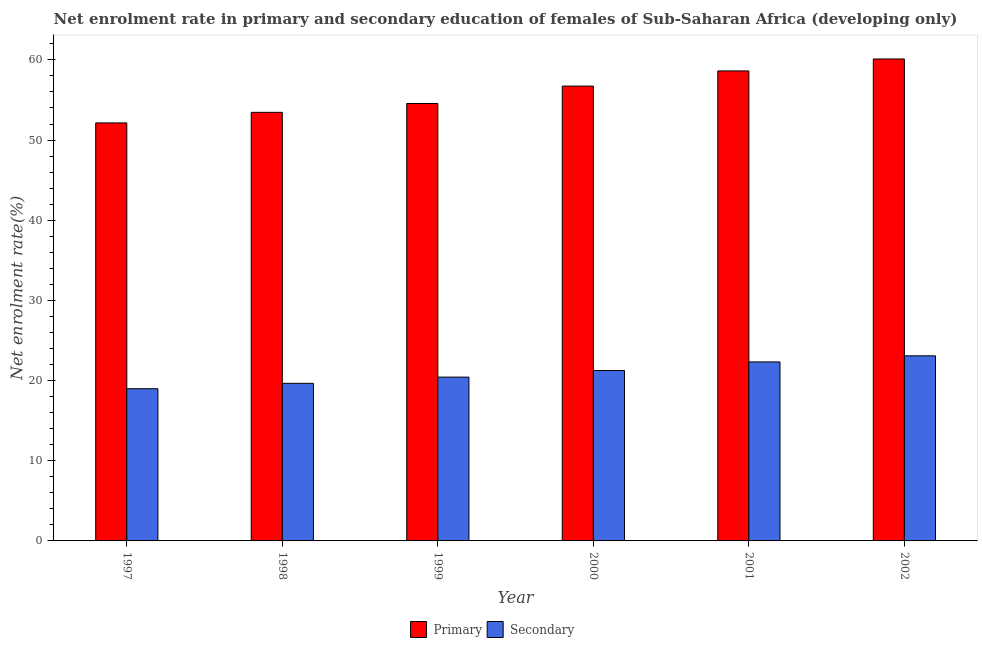How many different coloured bars are there?
Keep it short and to the point. 2. Are the number of bars on each tick of the X-axis equal?
Offer a very short reply. Yes. How many bars are there on the 6th tick from the left?
Give a very brief answer. 2. How many bars are there on the 2nd tick from the right?
Ensure brevity in your answer.  2. What is the enrollment rate in primary education in 1999?
Ensure brevity in your answer.  54.56. Across all years, what is the maximum enrollment rate in secondary education?
Make the answer very short. 23.09. Across all years, what is the minimum enrollment rate in secondary education?
Offer a very short reply. 18.99. In which year was the enrollment rate in primary education maximum?
Your response must be concise. 2002. What is the total enrollment rate in primary education in the graph?
Give a very brief answer. 335.63. What is the difference between the enrollment rate in primary education in 1998 and that in 2001?
Keep it short and to the point. -5.16. What is the difference between the enrollment rate in secondary education in 1998 and the enrollment rate in primary education in 2000?
Provide a short and direct response. -1.6. What is the average enrollment rate in secondary education per year?
Ensure brevity in your answer.  20.96. In the year 2000, what is the difference between the enrollment rate in primary education and enrollment rate in secondary education?
Ensure brevity in your answer.  0. What is the ratio of the enrollment rate in secondary education in 1998 to that in 2001?
Ensure brevity in your answer.  0.88. Is the enrollment rate in primary education in 2000 less than that in 2001?
Your answer should be compact. Yes. Is the difference between the enrollment rate in primary education in 1997 and 2000 greater than the difference between the enrollment rate in secondary education in 1997 and 2000?
Provide a succinct answer. No. What is the difference between the highest and the second highest enrollment rate in secondary education?
Your answer should be very brief. 0.76. What is the difference between the highest and the lowest enrollment rate in primary education?
Provide a short and direct response. 7.98. Is the sum of the enrollment rate in secondary education in 1997 and 2001 greater than the maximum enrollment rate in primary education across all years?
Your answer should be compact. Yes. What does the 1st bar from the left in 2001 represents?
Provide a short and direct response. Primary. What does the 1st bar from the right in 2001 represents?
Ensure brevity in your answer.  Secondary. What is the difference between two consecutive major ticks on the Y-axis?
Offer a terse response. 10. Are the values on the major ticks of Y-axis written in scientific E-notation?
Provide a short and direct response. No. Does the graph contain any zero values?
Make the answer very short. No. How many legend labels are there?
Make the answer very short. 2. How are the legend labels stacked?
Provide a succinct answer. Horizontal. What is the title of the graph?
Your answer should be compact. Net enrolment rate in primary and secondary education of females of Sub-Saharan Africa (developing only). What is the label or title of the Y-axis?
Offer a very short reply. Net enrolment rate(%). What is the Net enrolment rate(%) in Primary in 1997?
Your response must be concise. 52.14. What is the Net enrolment rate(%) of Secondary in 1997?
Offer a terse response. 18.99. What is the Net enrolment rate(%) of Primary in 1998?
Offer a very short reply. 53.46. What is the Net enrolment rate(%) of Secondary in 1998?
Ensure brevity in your answer.  19.66. What is the Net enrolment rate(%) in Primary in 1999?
Provide a succinct answer. 54.56. What is the Net enrolment rate(%) in Secondary in 1999?
Provide a short and direct response. 20.43. What is the Net enrolment rate(%) of Primary in 2000?
Offer a very short reply. 56.74. What is the Net enrolment rate(%) of Secondary in 2000?
Offer a terse response. 21.26. What is the Net enrolment rate(%) in Primary in 2001?
Keep it short and to the point. 58.62. What is the Net enrolment rate(%) in Secondary in 2001?
Ensure brevity in your answer.  22.33. What is the Net enrolment rate(%) of Primary in 2002?
Offer a terse response. 60.11. What is the Net enrolment rate(%) in Secondary in 2002?
Keep it short and to the point. 23.09. Across all years, what is the maximum Net enrolment rate(%) of Primary?
Offer a very short reply. 60.11. Across all years, what is the maximum Net enrolment rate(%) of Secondary?
Your answer should be very brief. 23.09. Across all years, what is the minimum Net enrolment rate(%) in Primary?
Offer a very short reply. 52.14. Across all years, what is the minimum Net enrolment rate(%) of Secondary?
Provide a short and direct response. 18.99. What is the total Net enrolment rate(%) of Primary in the graph?
Keep it short and to the point. 335.63. What is the total Net enrolment rate(%) of Secondary in the graph?
Your answer should be very brief. 125.74. What is the difference between the Net enrolment rate(%) of Primary in 1997 and that in 1998?
Provide a succinct answer. -1.32. What is the difference between the Net enrolment rate(%) of Secondary in 1997 and that in 1998?
Keep it short and to the point. -0.67. What is the difference between the Net enrolment rate(%) in Primary in 1997 and that in 1999?
Your response must be concise. -2.42. What is the difference between the Net enrolment rate(%) of Secondary in 1997 and that in 1999?
Ensure brevity in your answer.  -1.45. What is the difference between the Net enrolment rate(%) of Primary in 1997 and that in 2000?
Make the answer very short. -4.6. What is the difference between the Net enrolment rate(%) of Secondary in 1997 and that in 2000?
Keep it short and to the point. -2.27. What is the difference between the Net enrolment rate(%) of Primary in 1997 and that in 2001?
Offer a very short reply. -6.48. What is the difference between the Net enrolment rate(%) in Secondary in 1997 and that in 2001?
Provide a short and direct response. -3.34. What is the difference between the Net enrolment rate(%) of Primary in 1997 and that in 2002?
Offer a very short reply. -7.98. What is the difference between the Net enrolment rate(%) of Secondary in 1997 and that in 2002?
Make the answer very short. -4.1. What is the difference between the Net enrolment rate(%) of Primary in 1998 and that in 1999?
Keep it short and to the point. -1.1. What is the difference between the Net enrolment rate(%) of Secondary in 1998 and that in 1999?
Keep it short and to the point. -0.78. What is the difference between the Net enrolment rate(%) in Primary in 1998 and that in 2000?
Your response must be concise. -3.28. What is the difference between the Net enrolment rate(%) of Secondary in 1998 and that in 2000?
Give a very brief answer. -1.6. What is the difference between the Net enrolment rate(%) in Primary in 1998 and that in 2001?
Offer a very short reply. -5.16. What is the difference between the Net enrolment rate(%) of Secondary in 1998 and that in 2001?
Your answer should be very brief. -2.67. What is the difference between the Net enrolment rate(%) in Primary in 1998 and that in 2002?
Offer a terse response. -6.66. What is the difference between the Net enrolment rate(%) in Secondary in 1998 and that in 2002?
Offer a very short reply. -3.43. What is the difference between the Net enrolment rate(%) of Primary in 1999 and that in 2000?
Provide a succinct answer. -2.17. What is the difference between the Net enrolment rate(%) in Secondary in 1999 and that in 2000?
Provide a short and direct response. -0.83. What is the difference between the Net enrolment rate(%) in Primary in 1999 and that in 2001?
Give a very brief answer. -4.06. What is the difference between the Net enrolment rate(%) of Secondary in 1999 and that in 2001?
Make the answer very short. -1.89. What is the difference between the Net enrolment rate(%) in Primary in 1999 and that in 2002?
Offer a very short reply. -5.55. What is the difference between the Net enrolment rate(%) in Secondary in 1999 and that in 2002?
Provide a short and direct response. -2.66. What is the difference between the Net enrolment rate(%) of Primary in 2000 and that in 2001?
Keep it short and to the point. -1.89. What is the difference between the Net enrolment rate(%) in Secondary in 2000 and that in 2001?
Your response must be concise. -1.07. What is the difference between the Net enrolment rate(%) of Primary in 2000 and that in 2002?
Offer a terse response. -3.38. What is the difference between the Net enrolment rate(%) in Secondary in 2000 and that in 2002?
Give a very brief answer. -1.83. What is the difference between the Net enrolment rate(%) in Primary in 2001 and that in 2002?
Your answer should be very brief. -1.49. What is the difference between the Net enrolment rate(%) in Secondary in 2001 and that in 2002?
Your answer should be very brief. -0.76. What is the difference between the Net enrolment rate(%) in Primary in 1997 and the Net enrolment rate(%) in Secondary in 1998?
Keep it short and to the point. 32.48. What is the difference between the Net enrolment rate(%) in Primary in 1997 and the Net enrolment rate(%) in Secondary in 1999?
Your answer should be very brief. 31.71. What is the difference between the Net enrolment rate(%) of Primary in 1997 and the Net enrolment rate(%) of Secondary in 2000?
Your answer should be very brief. 30.88. What is the difference between the Net enrolment rate(%) of Primary in 1997 and the Net enrolment rate(%) of Secondary in 2001?
Keep it short and to the point. 29.81. What is the difference between the Net enrolment rate(%) of Primary in 1997 and the Net enrolment rate(%) of Secondary in 2002?
Your answer should be compact. 29.05. What is the difference between the Net enrolment rate(%) of Primary in 1998 and the Net enrolment rate(%) of Secondary in 1999?
Keep it short and to the point. 33.03. What is the difference between the Net enrolment rate(%) in Primary in 1998 and the Net enrolment rate(%) in Secondary in 2000?
Your response must be concise. 32.2. What is the difference between the Net enrolment rate(%) in Primary in 1998 and the Net enrolment rate(%) in Secondary in 2001?
Make the answer very short. 31.13. What is the difference between the Net enrolment rate(%) of Primary in 1998 and the Net enrolment rate(%) of Secondary in 2002?
Give a very brief answer. 30.37. What is the difference between the Net enrolment rate(%) in Primary in 1999 and the Net enrolment rate(%) in Secondary in 2000?
Your answer should be compact. 33.31. What is the difference between the Net enrolment rate(%) in Primary in 1999 and the Net enrolment rate(%) in Secondary in 2001?
Give a very brief answer. 32.24. What is the difference between the Net enrolment rate(%) in Primary in 1999 and the Net enrolment rate(%) in Secondary in 2002?
Make the answer very short. 31.47. What is the difference between the Net enrolment rate(%) in Primary in 2000 and the Net enrolment rate(%) in Secondary in 2001?
Make the answer very short. 34.41. What is the difference between the Net enrolment rate(%) in Primary in 2000 and the Net enrolment rate(%) in Secondary in 2002?
Offer a very short reply. 33.65. What is the difference between the Net enrolment rate(%) in Primary in 2001 and the Net enrolment rate(%) in Secondary in 2002?
Your answer should be compact. 35.53. What is the average Net enrolment rate(%) in Primary per year?
Keep it short and to the point. 55.94. What is the average Net enrolment rate(%) in Secondary per year?
Your answer should be compact. 20.96. In the year 1997, what is the difference between the Net enrolment rate(%) in Primary and Net enrolment rate(%) in Secondary?
Keep it short and to the point. 33.15. In the year 1998, what is the difference between the Net enrolment rate(%) of Primary and Net enrolment rate(%) of Secondary?
Provide a succinct answer. 33.8. In the year 1999, what is the difference between the Net enrolment rate(%) in Primary and Net enrolment rate(%) in Secondary?
Give a very brief answer. 34.13. In the year 2000, what is the difference between the Net enrolment rate(%) in Primary and Net enrolment rate(%) in Secondary?
Your answer should be very brief. 35.48. In the year 2001, what is the difference between the Net enrolment rate(%) of Primary and Net enrolment rate(%) of Secondary?
Make the answer very short. 36.3. In the year 2002, what is the difference between the Net enrolment rate(%) in Primary and Net enrolment rate(%) in Secondary?
Your answer should be very brief. 37.03. What is the ratio of the Net enrolment rate(%) of Primary in 1997 to that in 1998?
Offer a very short reply. 0.98. What is the ratio of the Net enrolment rate(%) of Secondary in 1997 to that in 1998?
Make the answer very short. 0.97. What is the ratio of the Net enrolment rate(%) in Primary in 1997 to that in 1999?
Provide a succinct answer. 0.96. What is the ratio of the Net enrolment rate(%) in Secondary in 1997 to that in 1999?
Your answer should be compact. 0.93. What is the ratio of the Net enrolment rate(%) of Primary in 1997 to that in 2000?
Offer a very short reply. 0.92. What is the ratio of the Net enrolment rate(%) of Secondary in 1997 to that in 2000?
Give a very brief answer. 0.89. What is the ratio of the Net enrolment rate(%) in Primary in 1997 to that in 2001?
Offer a very short reply. 0.89. What is the ratio of the Net enrolment rate(%) in Secondary in 1997 to that in 2001?
Offer a terse response. 0.85. What is the ratio of the Net enrolment rate(%) in Primary in 1997 to that in 2002?
Keep it short and to the point. 0.87. What is the ratio of the Net enrolment rate(%) of Secondary in 1997 to that in 2002?
Make the answer very short. 0.82. What is the ratio of the Net enrolment rate(%) in Primary in 1998 to that in 1999?
Your answer should be very brief. 0.98. What is the ratio of the Net enrolment rate(%) in Secondary in 1998 to that in 1999?
Your response must be concise. 0.96. What is the ratio of the Net enrolment rate(%) in Primary in 1998 to that in 2000?
Make the answer very short. 0.94. What is the ratio of the Net enrolment rate(%) of Secondary in 1998 to that in 2000?
Make the answer very short. 0.92. What is the ratio of the Net enrolment rate(%) in Primary in 1998 to that in 2001?
Give a very brief answer. 0.91. What is the ratio of the Net enrolment rate(%) of Secondary in 1998 to that in 2001?
Provide a short and direct response. 0.88. What is the ratio of the Net enrolment rate(%) in Primary in 1998 to that in 2002?
Provide a succinct answer. 0.89. What is the ratio of the Net enrolment rate(%) in Secondary in 1998 to that in 2002?
Provide a short and direct response. 0.85. What is the ratio of the Net enrolment rate(%) in Primary in 1999 to that in 2000?
Offer a terse response. 0.96. What is the ratio of the Net enrolment rate(%) of Secondary in 1999 to that in 2000?
Keep it short and to the point. 0.96. What is the ratio of the Net enrolment rate(%) in Primary in 1999 to that in 2001?
Make the answer very short. 0.93. What is the ratio of the Net enrolment rate(%) in Secondary in 1999 to that in 2001?
Provide a short and direct response. 0.92. What is the ratio of the Net enrolment rate(%) in Primary in 1999 to that in 2002?
Offer a very short reply. 0.91. What is the ratio of the Net enrolment rate(%) in Secondary in 1999 to that in 2002?
Your response must be concise. 0.88. What is the ratio of the Net enrolment rate(%) in Primary in 2000 to that in 2001?
Ensure brevity in your answer.  0.97. What is the ratio of the Net enrolment rate(%) of Secondary in 2000 to that in 2001?
Provide a short and direct response. 0.95. What is the ratio of the Net enrolment rate(%) of Primary in 2000 to that in 2002?
Ensure brevity in your answer.  0.94. What is the ratio of the Net enrolment rate(%) of Secondary in 2000 to that in 2002?
Offer a terse response. 0.92. What is the ratio of the Net enrolment rate(%) in Primary in 2001 to that in 2002?
Make the answer very short. 0.98. What is the ratio of the Net enrolment rate(%) of Secondary in 2001 to that in 2002?
Keep it short and to the point. 0.97. What is the difference between the highest and the second highest Net enrolment rate(%) of Primary?
Your answer should be compact. 1.49. What is the difference between the highest and the second highest Net enrolment rate(%) of Secondary?
Your response must be concise. 0.76. What is the difference between the highest and the lowest Net enrolment rate(%) of Primary?
Your answer should be very brief. 7.98. What is the difference between the highest and the lowest Net enrolment rate(%) of Secondary?
Give a very brief answer. 4.1. 